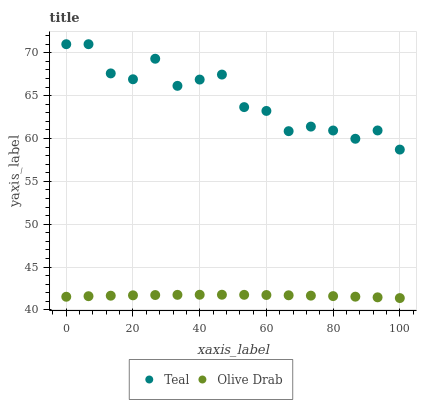Does Olive Drab have the minimum area under the curve?
Answer yes or no. Yes. Does Teal have the maximum area under the curve?
Answer yes or no. Yes. Does Teal have the minimum area under the curve?
Answer yes or no. No. Is Olive Drab the smoothest?
Answer yes or no. Yes. Is Teal the roughest?
Answer yes or no. Yes. Is Teal the smoothest?
Answer yes or no. No. Does Olive Drab have the lowest value?
Answer yes or no. Yes. Does Teal have the lowest value?
Answer yes or no. No. Does Teal have the highest value?
Answer yes or no. Yes. Is Olive Drab less than Teal?
Answer yes or no. Yes. Is Teal greater than Olive Drab?
Answer yes or no. Yes. Does Olive Drab intersect Teal?
Answer yes or no. No. 